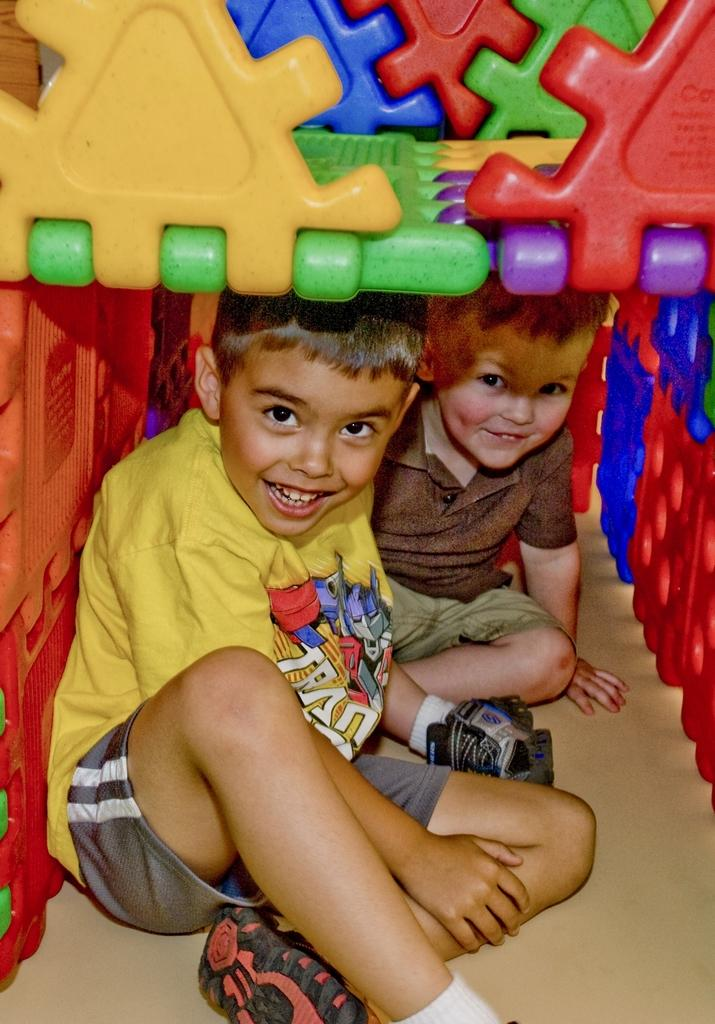How many children are in the image? There are two children in the image. What are the children doing in the image? The children are sitting. What are the children wearing in the image? The children are wearing clothes, socks, and shoes. What is the emotional expression of the children in the image? The children are smiling. What object can be seen in the image besides the children? There is a toy log in the image. How does the image show a quiet environment? The image does not show a quiet environment; the children are smiling, which suggests they are not in a quiet setting. 